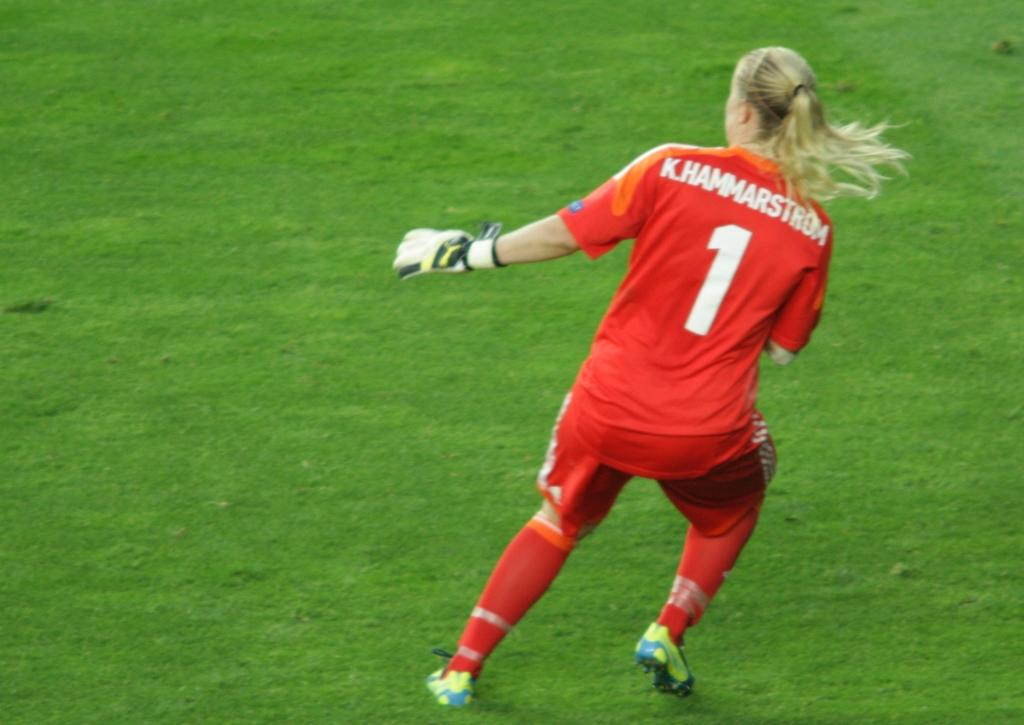<image>
Provide a brief description of the given image. a female soccer player on the field with the number 1 on the back of her jersey 